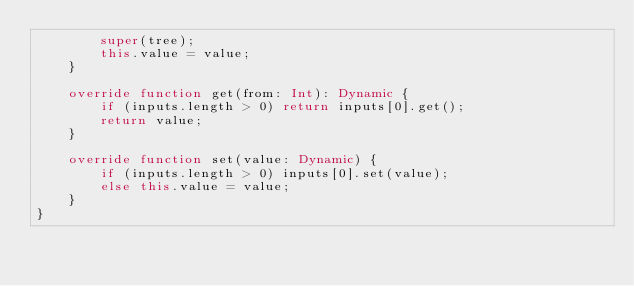<code> <loc_0><loc_0><loc_500><loc_500><_Haxe_>		super(tree);
		this.value = value;
	}

	override function get(from: Int): Dynamic {
		if (inputs.length > 0) return inputs[0].get();
		return value;
	}

	override function set(value: Dynamic) {
		if (inputs.length > 0) inputs[0].set(value);
		else this.value = value;
	}
}
</code> 